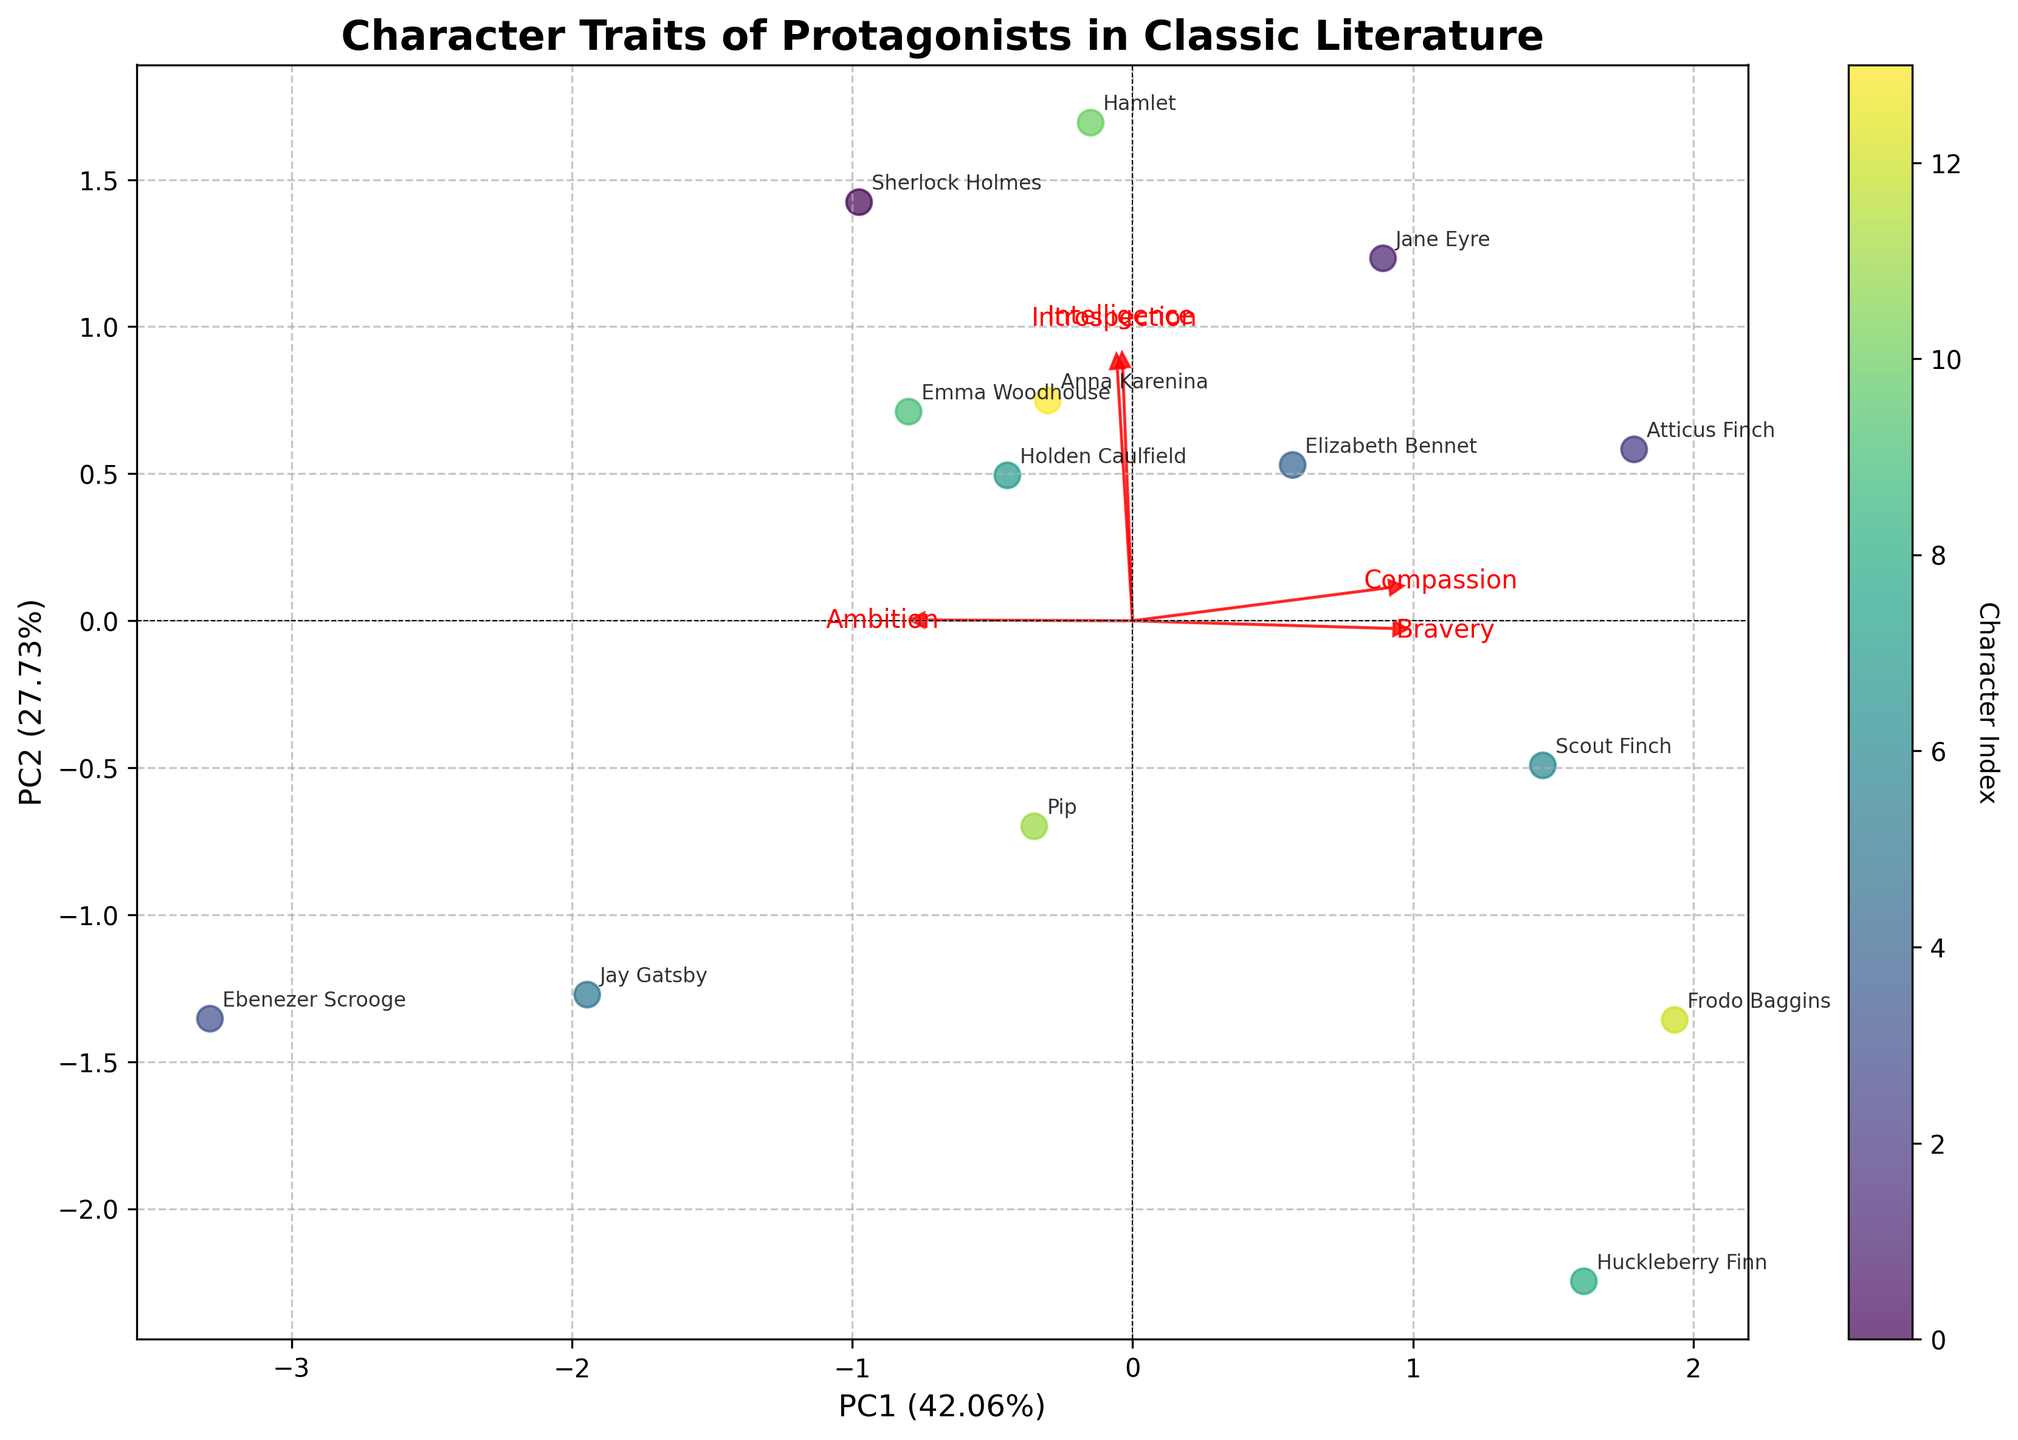Which character appears closest to the origin on the biplot? The origin is where the axes intersect at (0,0). The character closest to this point resembles neutrality in the PCA loadings
Answer: Anna Karenina Which trait contributes most to the first Principal Component (PC1)? The loadings of the PCA components, displayed as arrows, illustrate the contributions of each trait to the Principal Components. The length and direction of each arrow determine the contribution
Answer: Intelligence How closely do the characters Elizabeth Bennet and Frodo Baggins group together? To determine this, locate the positions of Elizabeth Bennet and Frodo Baggins on the biplot and observe the distance between them
Answer: They are fairly close What is the combined score on PC1 and PC2 for Holden Caulfield? Locate Holden Caulfield on the biplot and find his coordinates on both PC1 and PC2 then sum these values
Answer: (-3.5, 1) How does the ambition trait differentiate Sherlock Holmes and Jay Gatsby? Look at the direction and length of the Ambition arrow and compare the positions of Sherlock Holmes and Jay Gatsby relative to this arrow
Answer: Jay Gatsby scores higher on ambition Which character is highly introspective but low in compassion according to the biplot? Identify the direction of the introspection and compassion arrows. Find a character positioned towards high introspection and low compassion
Answer: Hamlet Which two characters have the most similar profiles in terms of bravery and intelligence? Examine the biplot and look for characters that closely align in the directions of bravery and intelligence vectors
Answer: Sherlock Holmes and Elizabeth Bennet What does the spacing of characters along the first principal component indicate? The spread along the PC1 axis indicates how much they differ based on traits weighted most heavily in PC1
Answer: Diversity in intelligence and ambition How do characters associated with high compassion compare in their intelligence scores? Look at characters positioned along the compassion axis and compare their locations along the intelligence axis too
Answer: Jane Eyre and Atticus Finch show high compassion and high intelligence 